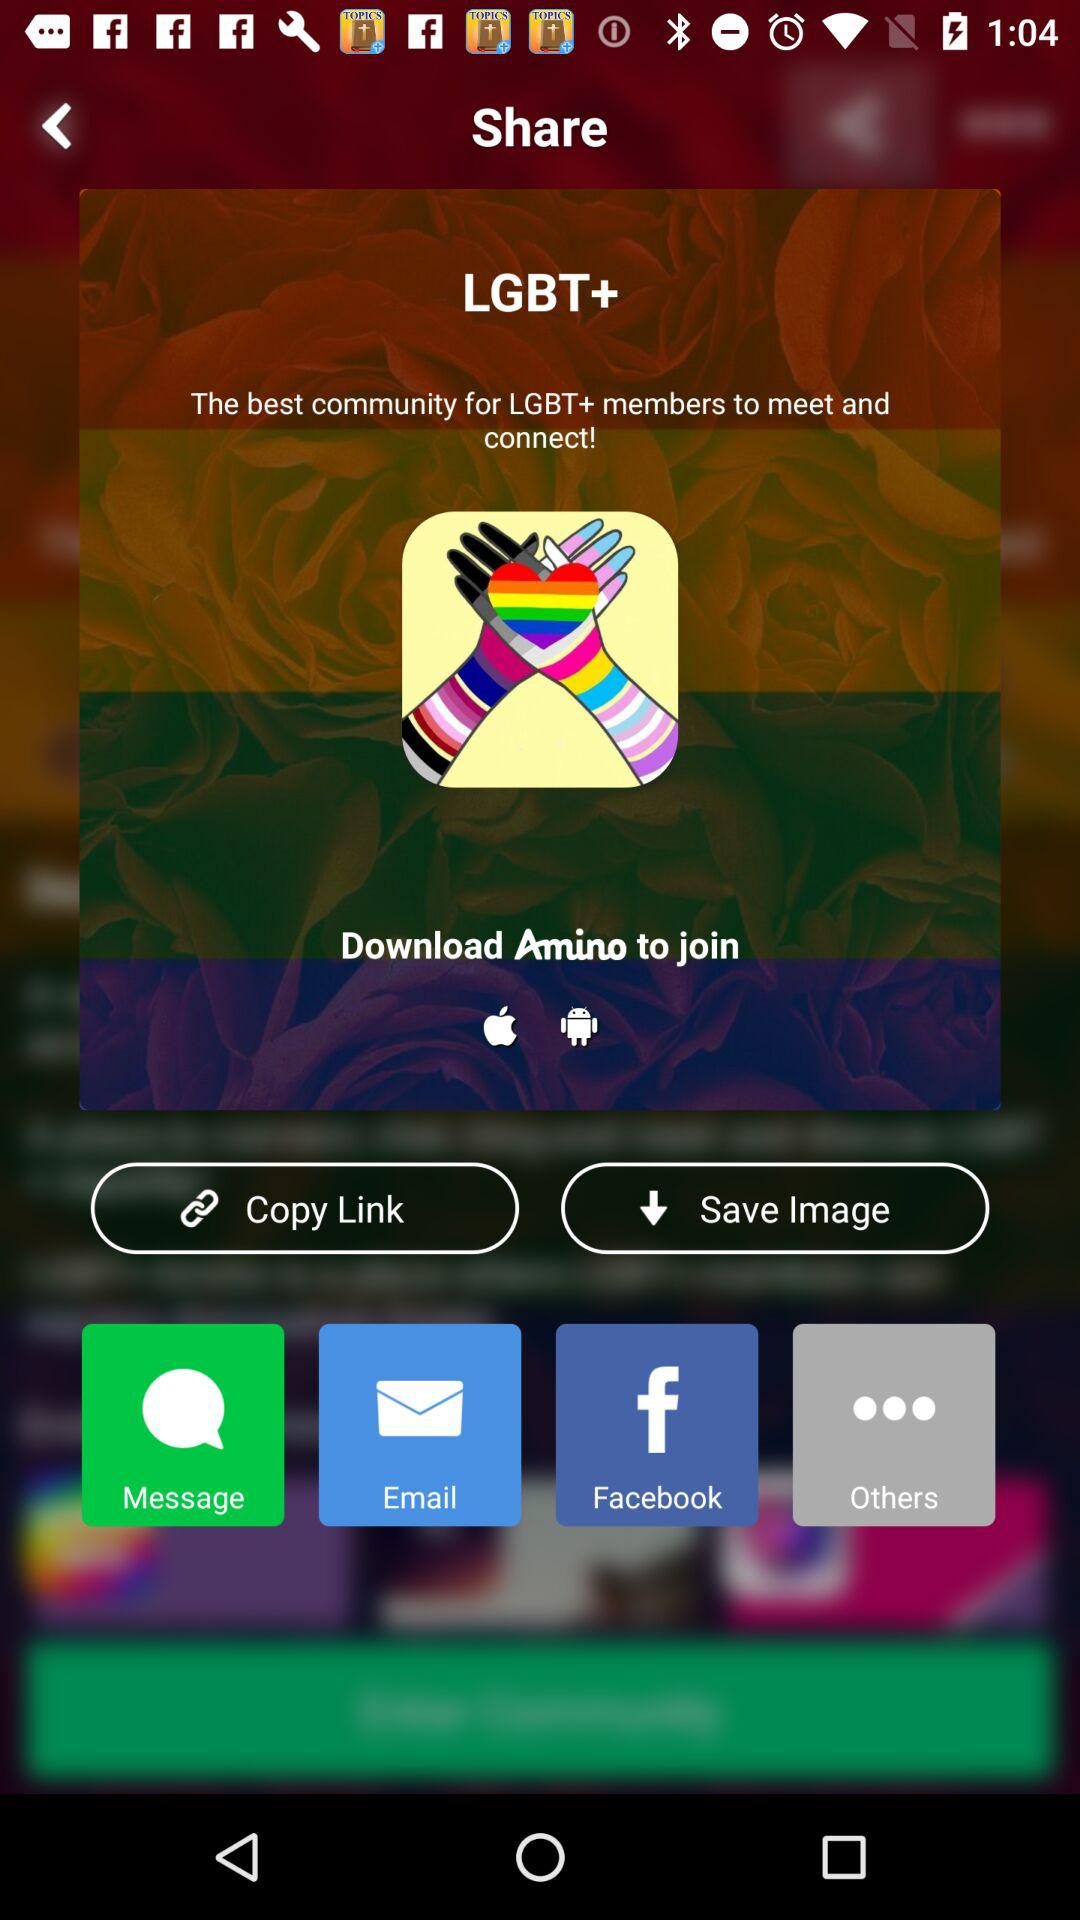From which app we can share? The apps you can share with are "Message", "Email" and "Facebook". 